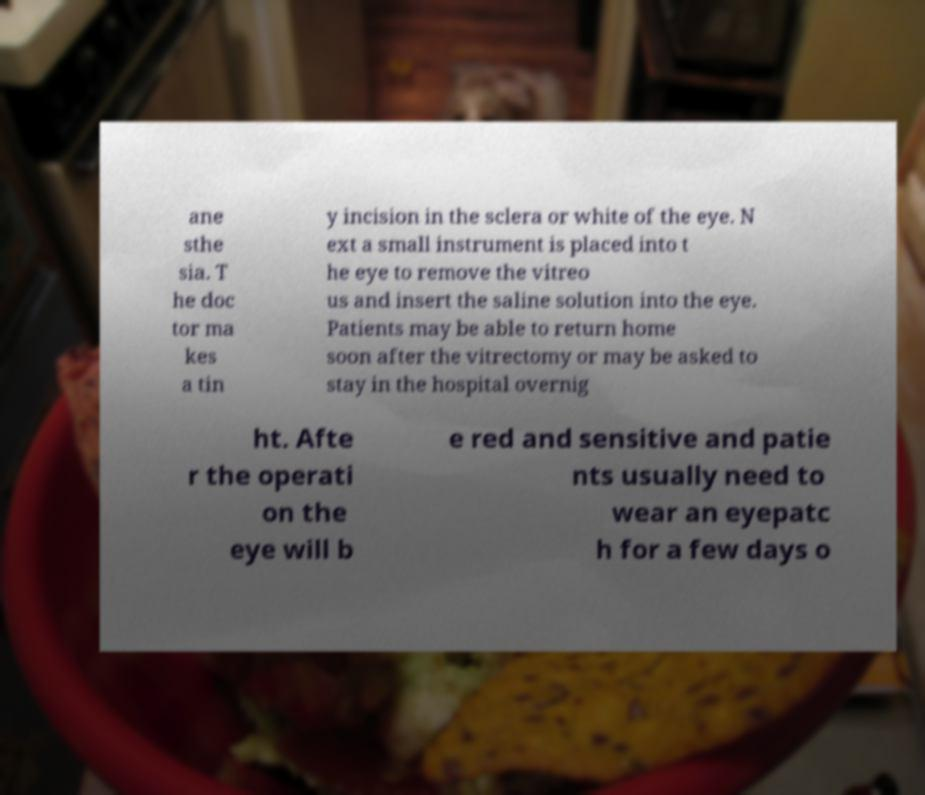Could you extract and type out the text from this image? ane sthe sia. T he doc tor ma kes a tin y incision in the sclera or white of the eye. N ext a small instrument is placed into t he eye to remove the vitreo us and insert the saline solution into the eye. Patients may be able to return home soon after the vitrectomy or may be asked to stay in the hospital overnig ht. Afte r the operati on the eye will b e red and sensitive and patie nts usually need to wear an eyepatc h for a few days o 